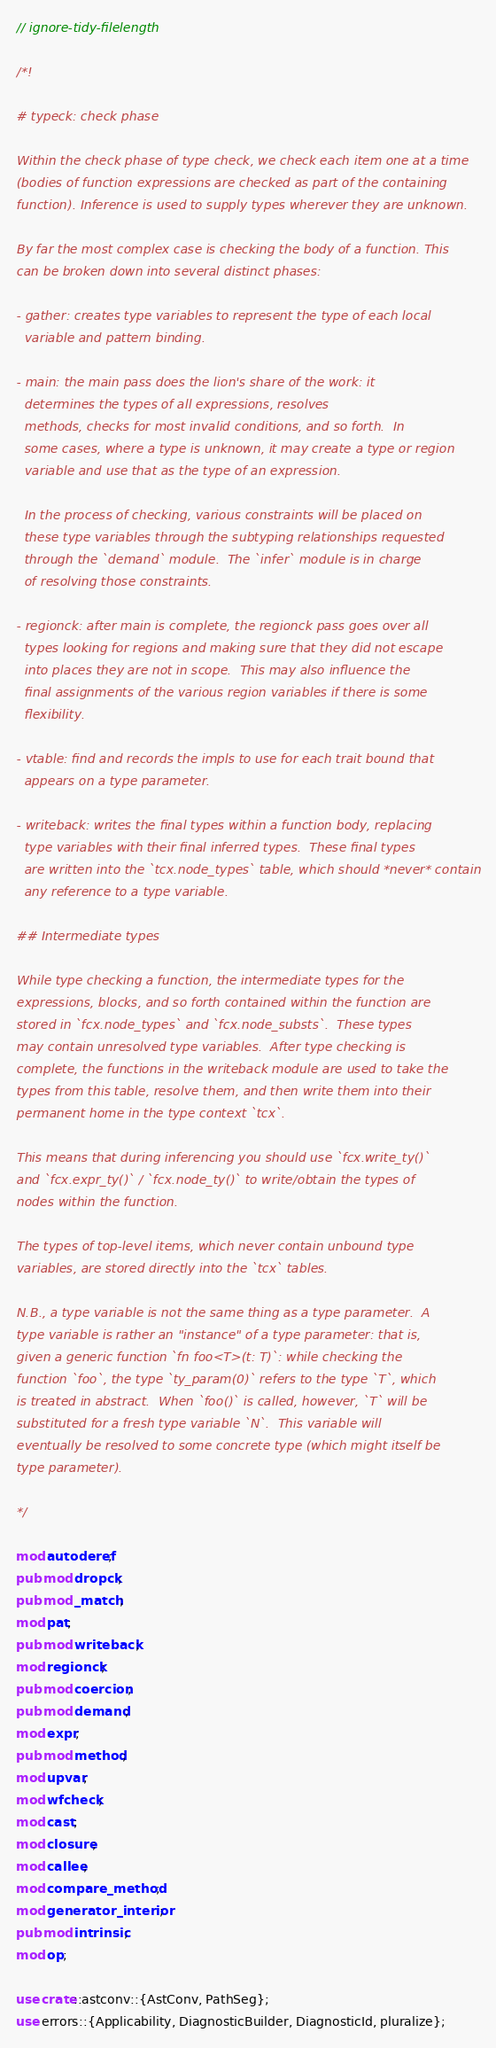<code> <loc_0><loc_0><loc_500><loc_500><_Rust_>// ignore-tidy-filelength

/*!

# typeck: check phase

Within the check phase of type check, we check each item one at a time
(bodies of function expressions are checked as part of the containing
function). Inference is used to supply types wherever they are unknown.

By far the most complex case is checking the body of a function. This
can be broken down into several distinct phases:

- gather: creates type variables to represent the type of each local
  variable and pattern binding.

- main: the main pass does the lion's share of the work: it
  determines the types of all expressions, resolves
  methods, checks for most invalid conditions, and so forth.  In
  some cases, where a type is unknown, it may create a type or region
  variable and use that as the type of an expression.

  In the process of checking, various constraints will be placed on
  these type variables through the subtyping relationships requested
  through the `demand` module.  The `infer` module is in charge
  of resolving those constraints.

- regionck: after main is complete, the regionck pass goes over all
  types looking for regions and making sure that they did not escape
  into places they are not in scope.  This may also influence the
  final assignments of the various region variables if there is some
  flexibility.

- vtable: find and records the impls to use for each trait bound that
  appears on a type parameter.

- writeback: writes the final types within a function body, replacing
  type variables with their final inferred types.  These final types
  are written into the `tcx.node_types` table, which should *never* contain
  any reference to a type variable.

## Intermediate types

While type checking a function, the intermediate types for the
expressions, blocks, and so forth contained within the function are
stored in `fcx.node_types` and `fcx.node_substs`.  These types
may contain unresolved type variables.  After type checking is
complete, the functions in the writeback module are used to take the
types from this table, resolve them, and then write them into their
permanent home in the type context `tcx`.

This means that during inferencing you should use `fcx.write_ty()`
and `fcx.expr_ty()` / `fcx.node_ty()` to write/obtain the types of
nodes within the function.

The types of top-level items, which never contain unbound type
variables, are stored directly into the `tcx` tables.

N.B., a type variable is not the same thing as a type parameter.  A
type variable is rather an "instance" of a type parameter: that is,
given a generic function `fn foo<T>(t: T)`: while checking the
function `foo`, the type `ty_param(0)` refers to the type `T`, which
is treated in abstract.  When `foo()` is called, however, `T` will be
substituted for a fresh type variable `N`.  This variable will
eventually be resolved to some concrete type (which might itself be
type parameter).

*/

mod autoderef;
pub mod dropck;
pub mod _match;
mod pat;
pub mod writeback;
mod regionck;
pub mod coercion;
pub mod demand;
mod expr;
pub mod method;
mod upvar;
mod wfcheck;
mod cast;
mod closure;
mod callee;
mod compare_method;
mod generator_interior;
pub mod intrinsic;
mod op;

use crate::astconv::{AstConv, PathSeg};
use errors::{Applicability, DiagnosticBuilder, DiagnosticId, pluralize};</code> 